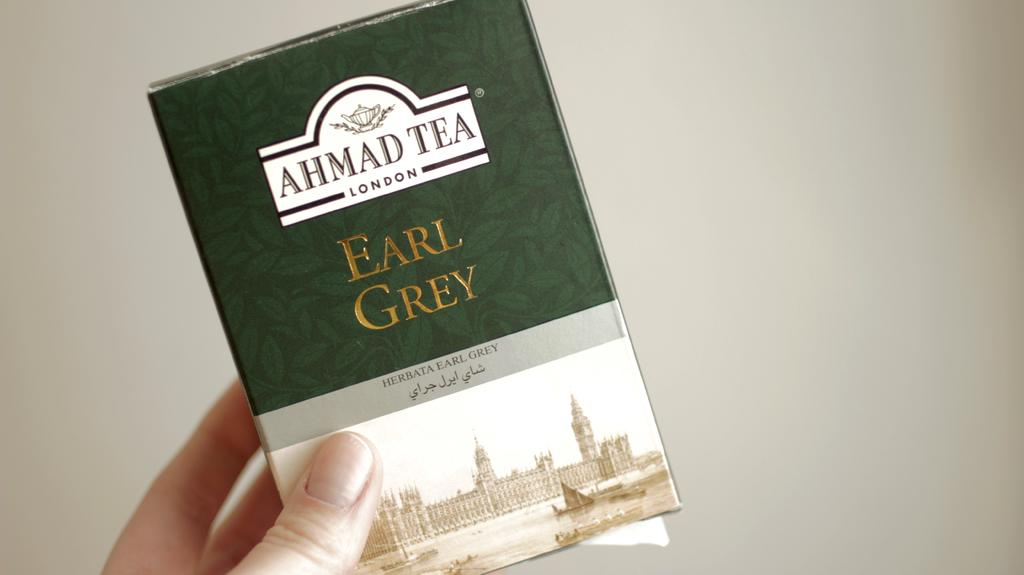<image>
Write a terse but informative summary of the picture. A package of Ahmad Tea by Earl Grey of London. 